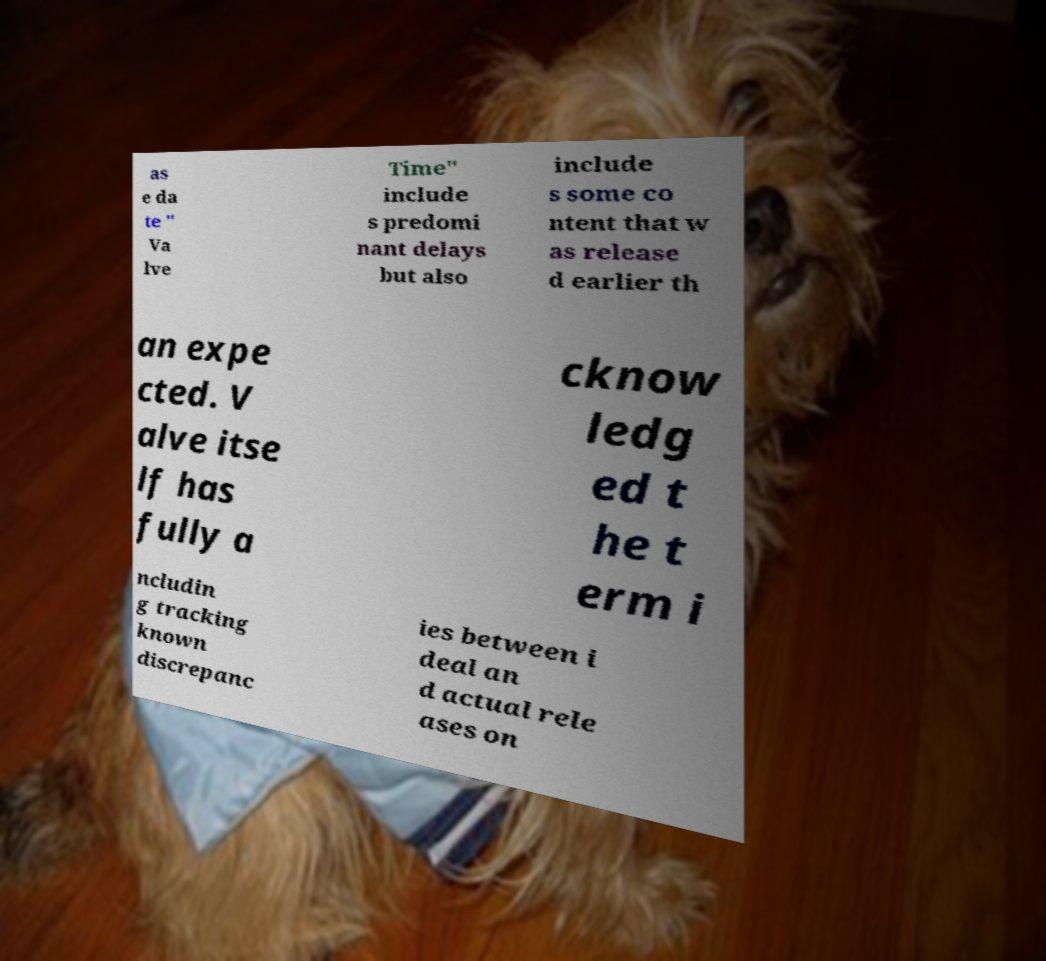I need the written content from this picture converted into text. Can you do that? as e da te " Va lve Time" include s predomi nant delays but also include s some co ntent that w as release d earlier th an expe cted. V alve itse lf has fully a cknow ledg ed t he t erm i ncludin g tracking known discrepanc ies between i deal an d actual rele ases on 